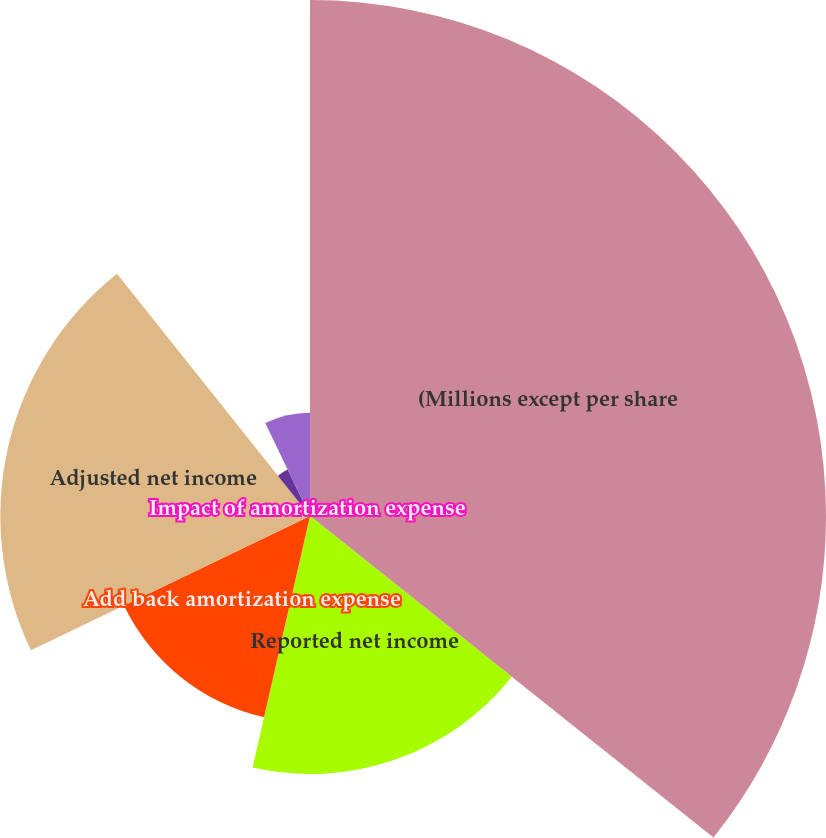Convert chart to OTSL. <chart><loc_0><loc_0><loc_500><loc_500><pie_chart><fcel>(Millions except per share<fcel>Reported net income<fcel>Add back amortization expense<fcel>Adjusted net income<fcel>Reported earnings<fcel>Impact of amortization expense<fcel>Adjusted earnings per common<nl><fcel>35.71%<fcel>17.86%<fcel>14.29%<fcel>21.43%<fcel>3.57%<fcel>0.0%<fcel>7.14%<nl></chart> 